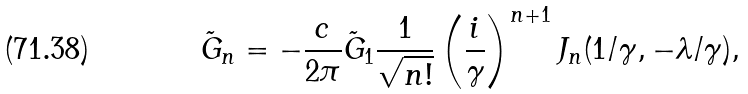<formula> <loc_0><loc_0><loc_500><loc_500>\tilde { G } _ { n } = - \frac { c } { 2 \pi } \tilde { G } _ { 1 } \frac { 1 } { \sqrt { n ! } } \left ( \frac { i } { \gamma } \right ) ^ { n + 1 } J _ { n } ( 1 / \gamma , - \lambda / \gamma ) ,</formula> 